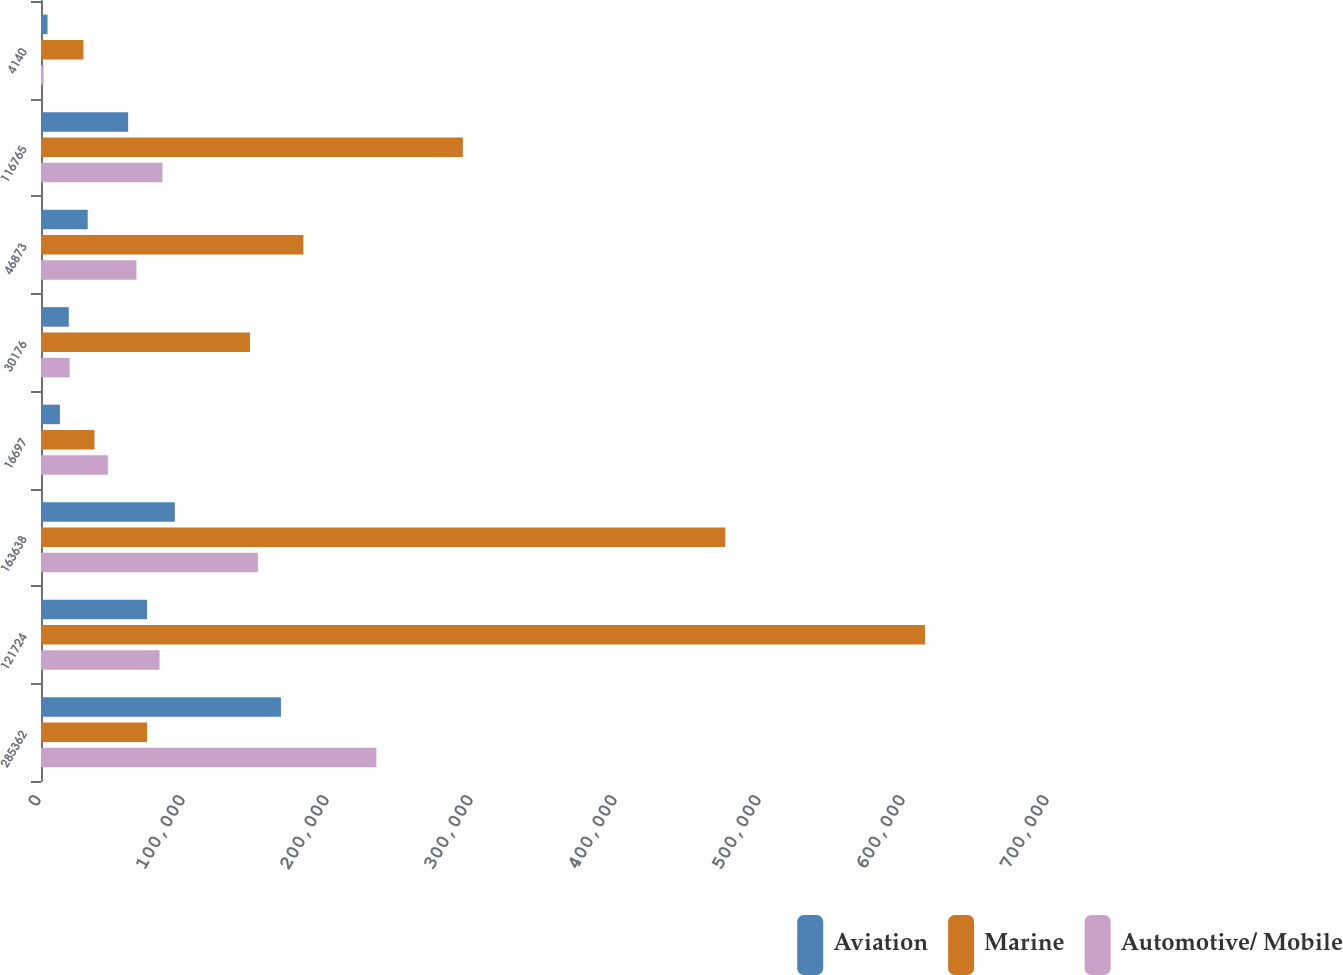Convert chart to OTSL. <chart><loc_0><loc_0><loc_500><loc_500><stacked_bar_chart><ecel><fcel>285362<fcel>121724<fcel>163638<fcel>16697<fcel>30176<fcel>46873<fcel>116765<fcel>4140<nl><fcel>Aviation<fcel>166639<fcel>73687<fcel>92952<fcel>13121<fcel>19307<fcel>32428<fcel>60524<fcel>4563<nl><fcel>Marine<fcel>73687<fcel>613902<fcel>475191<fcel>37125<fcel>145113<fcel>182238<fcel>292953<fcel>29468<nl><fcel>Automotive/ Mobile<fcel>232906<fcel>82301<fcel>150605<fcel>46371<fcel>19917<fcel>66288<fcel>84317<fcel>1824<nl></chart> 